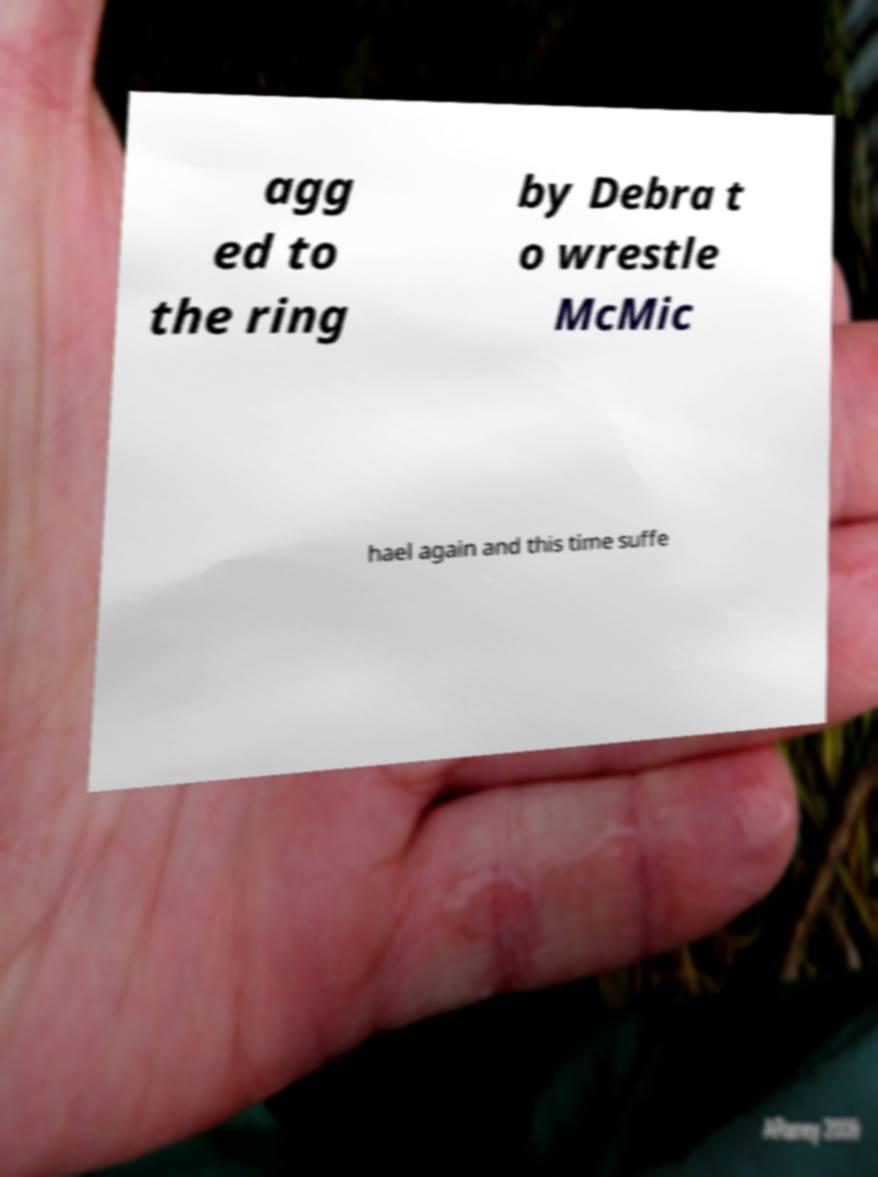Please read and relay the text visible in this image. What does it say? agg ed to the ring by Debra t o wrestle McMic hael again and this time suffe 